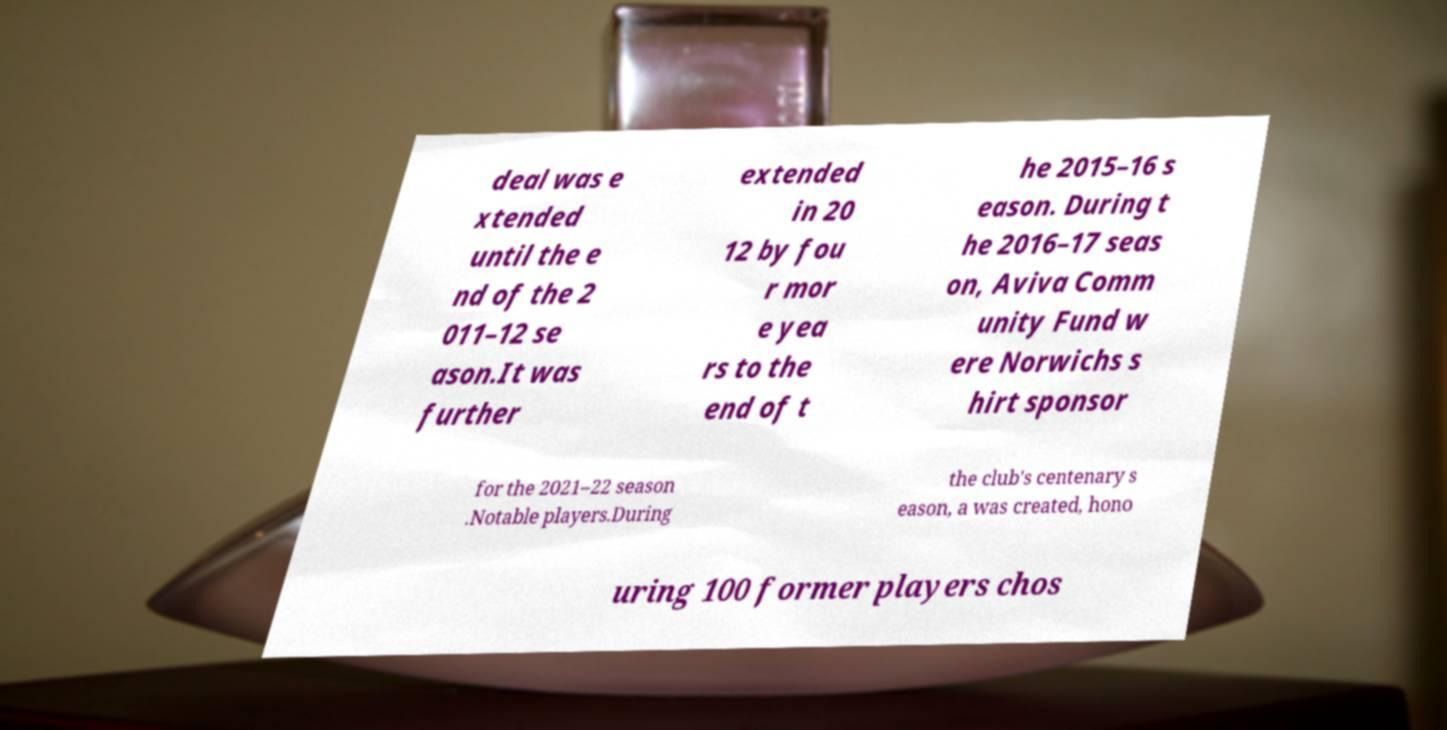Please identify and transcribe the text found in this image. deal was e xtended until the e nd of the 2 011–12 se ason.It was further extended in 20 12 by fou r mor e yea rs to the end of t he 2015–16 s eason. During t he 2016–17 seas on, Aviva Comm unity Fund w ere Norwichs s hirt sponsor for the 2021–22 season .Notable players.During the club's centenary s eason, a was created, hono uring 100 former players chos 